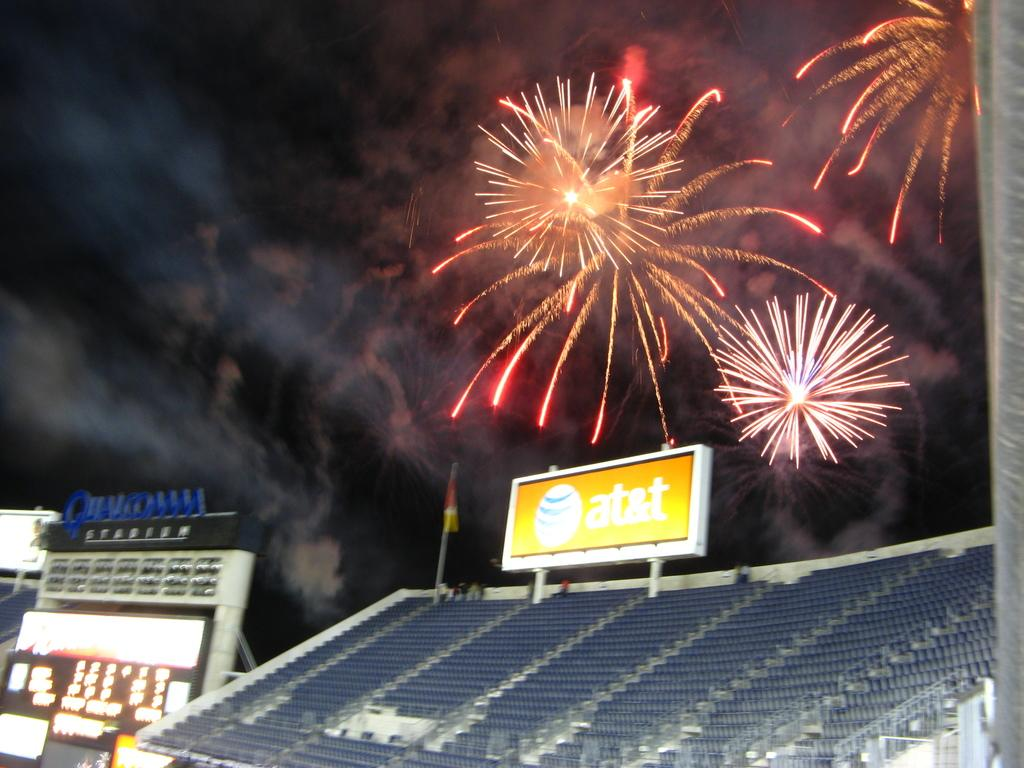<image>
Describe the image concisely. A large empty stadium has an at&t sign with fireworks going off above. 